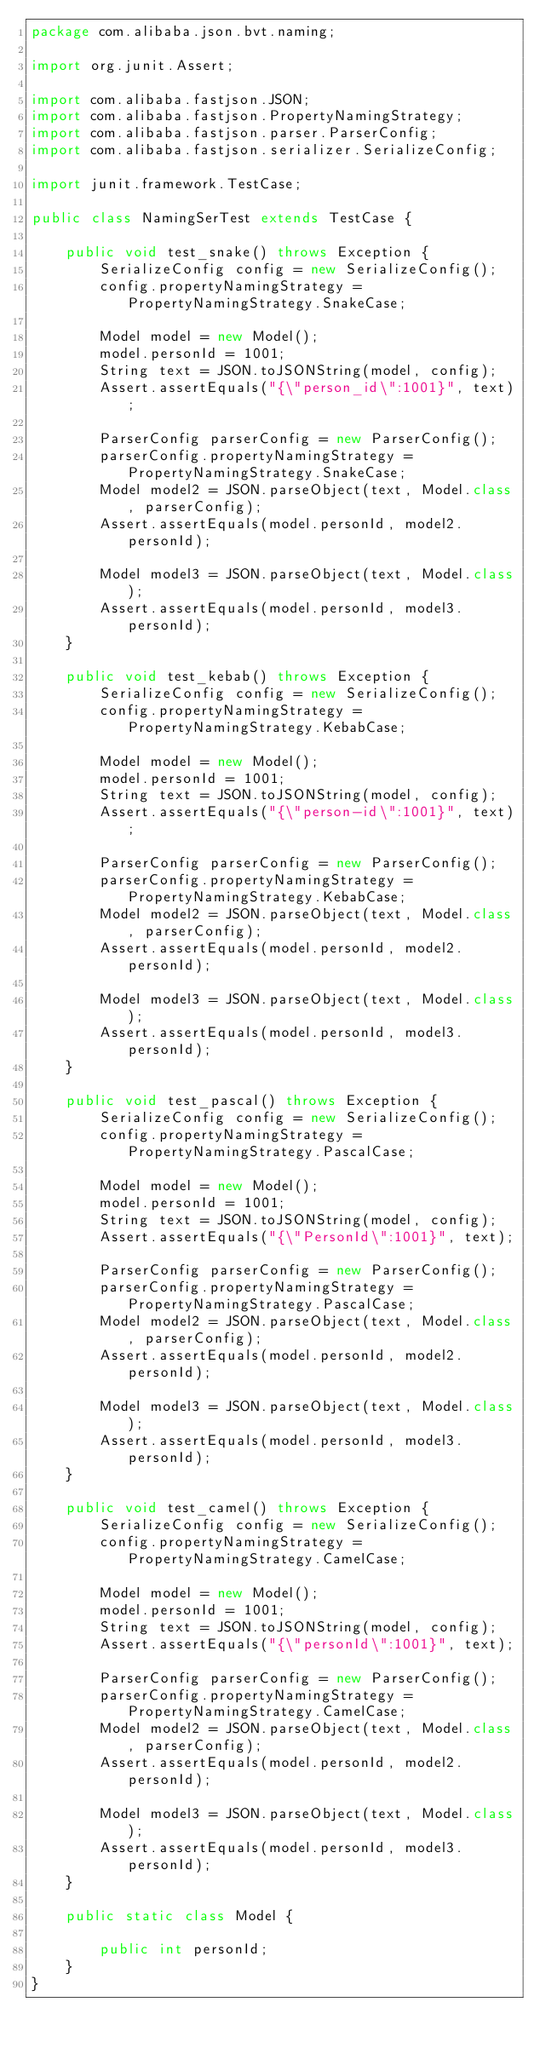Convert code to text. <code><loc_0><loc_0><loc_500><loc_500><_Java_>package com.alibaba.json.bvt.naming;

import org.junit.Assert;

import com.alibaba.fastjson.JSON;
import com.alibaba.fastjson.PropertyNamingStrategy;
import com.alibaba.fastjson.parser.ParserConfig;
import com.alibaba.fastjson.serializer.SerializeConfig;

import junit.framework.TestCase;

public class NamingSerTest extends TestCase {

    public void test_snake() throws Exception {
        SerializeConfig config = new SerializeConfig();
        config.propertyNamingStrategy = PropertyNamingStrategy.SnakeCase;

        Model model = new Model();
        model.personId = 1001;
        String text = JSON.toJSONString(model, config);
        Assert.assertEquals("{\"person_id\":1001}", text);

        ParserConfig parserConfig = new ParserConfig();
        parserConfig.propertyNamingStrategy = PropertyNamingStrategy.SnakeCase;
        Model model2 = JSON.parseObject(text, Model.class, parserConfig);
        Assert.assertEquals(model.personId, model2.personId);

        Model model3 = JSON.parseObject(text, Model.class);
        Assert.assertEquals(model.personId, model3.personId);
    }

    public void test_kebab() throws Exception {
        SerializeConfig config = new SerializeConfig();
        config.propertyNamingStrategy = PropertyNamingStrategy.KebabCase;

        Model model = new Model();
        model.personId = 1001;
        String text = JSON.toJSONString(model, config);
        Assert.assertEquals("{\"person-id\":1001}", text);
        
        ParserConfig parserConfig = new ParserConfig();
        parserConfig.propertyNamingStrategy = PropertyNamingStrategy.KebabCase;
        Model model2 = JSON.parseObject(text, Model.class, parserConfig);
        Assert.assertEquals(model.personId, model2.personId);

        Model model3 = JSON.parseObject(text, Model.class);
        Assert.assertEquals(model.personId, model3.personId);
    }

    public void test_pascal() throws Exception {
        SerializeConfig config = new SerializeConfig();
        config.propertyNamingStrategy = PropertyNamingStrategy.PascalCase;

        Model model = new Model();
        model.personId = 1001;
        String text = JSON.toJSONString(model, config);
        Assert.assertEquals("{\"PersonId\":1001}", text);
        
        ParserConfig parserConfig = new ParserConfig();
        parserConfig.propertyNamingStrategy = PropertyNamingStrategy.PascalCase;
        Model model2 = JSON.parseObject(text, Model.class, parserConfig);
        Assert.assertEquals(model.personId, model2.personId);

        Model model3 = JSON.parseObject(text, Model.class);
        Assert.assertEquals(model.personId, model3.personId);
    }

    public void test_camel() throws Exception {
        SerializeConfig config = new SerializeConfig();
        config.propertyNamingStrategy = PropertyNamingStrategy.CamelCase;

        Model model = new Model();
        model.personId = 1001;
        String text = JSON.toJSONString(model, config);
        Assert.assertEquals("{\"personId\":1001}", text);
        
        ParserConfig parserConfig = new ParserConfig();
        parserConfig.propertyNamingStrategy = PropertyNamingStrategy.CamelCase;
        Model model2 = JSON.parseObject(text, Model.class, parserConfig);
        Assert.assertEquals(model.personId, model2.personId);

        Model model3 = JSON.parseObject(text, Model.class);
        Assert.assertEquals(model.personId, model3.personId);
    }

    public static class Model {

        public int personId;
    }
}
</code> 